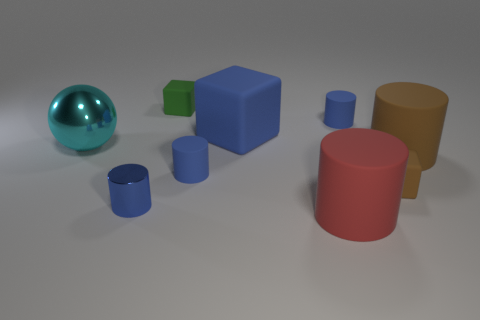Are the tiny blue cylinder that is behind the metallic ball and the large thing that is behind the big cyan metallic sphere made of the same material?
Your answer should be compact. Yes. Is there any other thing that is the same shape as the big red matte thing?
Give a very brief answer. Yes. Are the red object and the big cylinder behind the blue metallic object made of the same material?
Your answer should be very brief. Yes. The rubber object that is in front of the brown rubber object in front of the large thing that is to the right of the big red cylinder is what color?
Your answer should be very brief. Red. What shape is the brown thing that is the same size as the metal sphere?
Provide a succinct answer. Cylinder. Do the blue matte cylinder behind the brown cylinder and the green block to the left of the blue matte block have the same size?
Offer a very short reply. Yes. What size is the matte cylinder right of the brown matte cube?
Offer a terse response. Large. There is a large thing that is the same color as the tiny metallic cylinder; what is its material?
Your answer should be very brief. Rubber. There is a rubber block that is the same size as the cyan shiny object; what is its color?
Provide a succinct answer. Blue. Do the red rubber object and the blue cube have the same size?
Your answer should be very brief. Yes. 